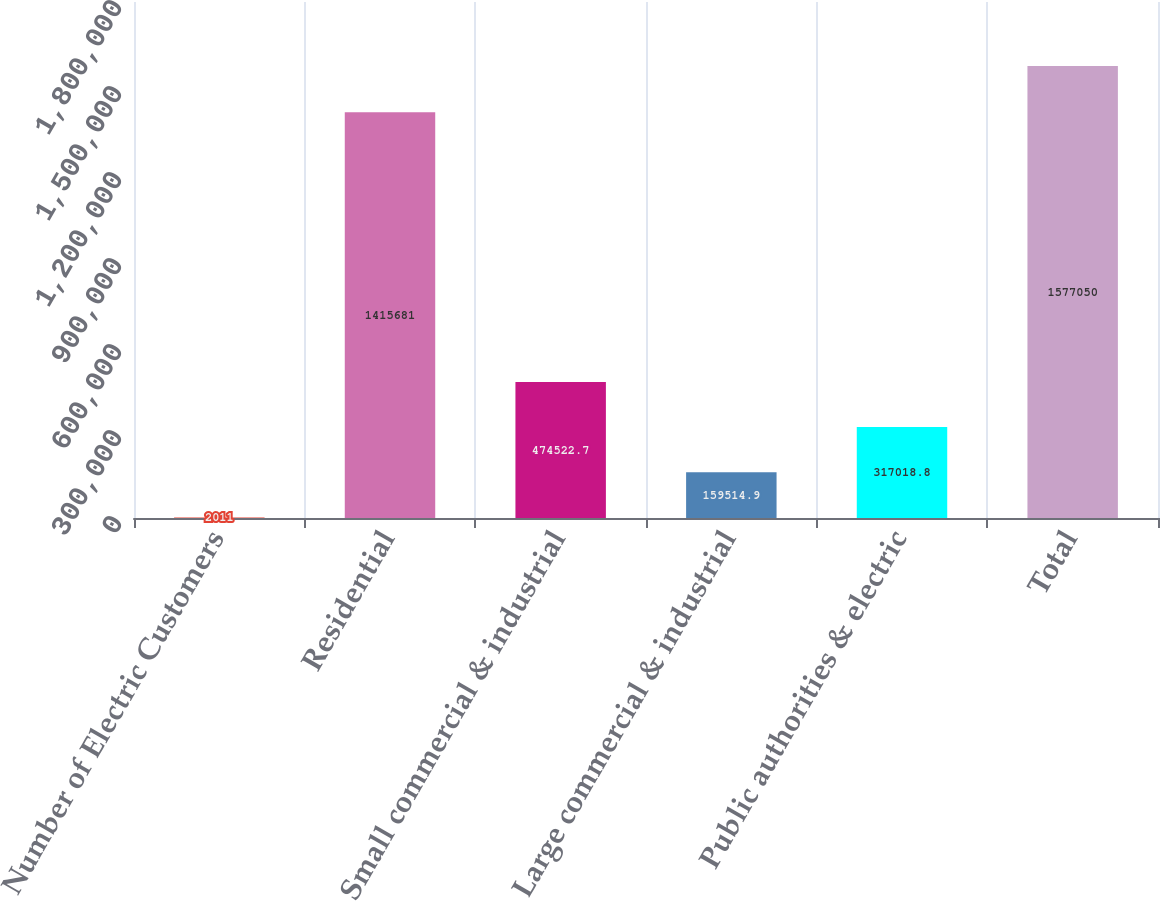Convert chart. <chart><loc_0><loc_0><loc_500><loc_500><bar_chart><fcel>Number of Electric Customers<fcel>Residential<fcel>Small commercial & industrial<fcel>Large commercial & industrial<fcel>Public authorities & electric<fcel>Total<nl><fcel>2011<fcel>1.41568e+06<fcel>474523<fcel>159515<fcel>317019<fcel>1.57705e+06<nl></chart> 